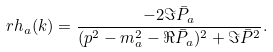<formula> <loc_0><loc_0><loc_500><loc_500>\ r h _ { a } ( k ) = \frac { - 2 \Im \bar { P } _ { a } } { ( p ^ { 2 } - m _ { a } ^ { 2 } - \Re \bar { P } _ { a } ) ^ { 2 } + \Im \bar { P } ^ { 2 } } .</formula> 